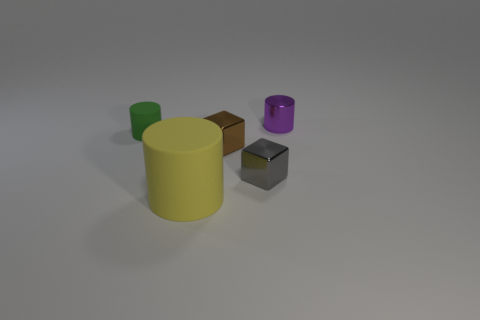Are there any other things that have the same color as the metal cylinder?
Offer a very short reply. No. Is the material of the small gray cube the same as the small cylinder that is on the left side of the tiny purple metal object?
Keep it short and to the point. No. What material is the other small thing that is the same shape as the tiny purple thing?
Offer a very short reply. Rubber. Is the material of the cylinder that is in front of the small green matte cylinder the same as the small cube behind the gray metal thing?
Ensure brevity in your answer.  No. There is a cylinder in front of the small cylinder in front of the tiny thing that is behind the tiny green cylinder; what color is it?
Your answer should be compact. Yellow. How many other things are there of the same shape as the brown thing?
Make the answer very short. 1. Is the color of the small matte cylinder the same as the big matte object?
Provide a succinct answer. No. How many objects are small brown shiny objects or rubber cylinders that are in front of the tiny gray shiny object?
Provide a succinct answer. 2. Is there another green matte object of the same size as the green thing?
Offer a terse response. No. Are the small brown object and the big cylinder made of the same material?
Provide a succinct answer. No. 